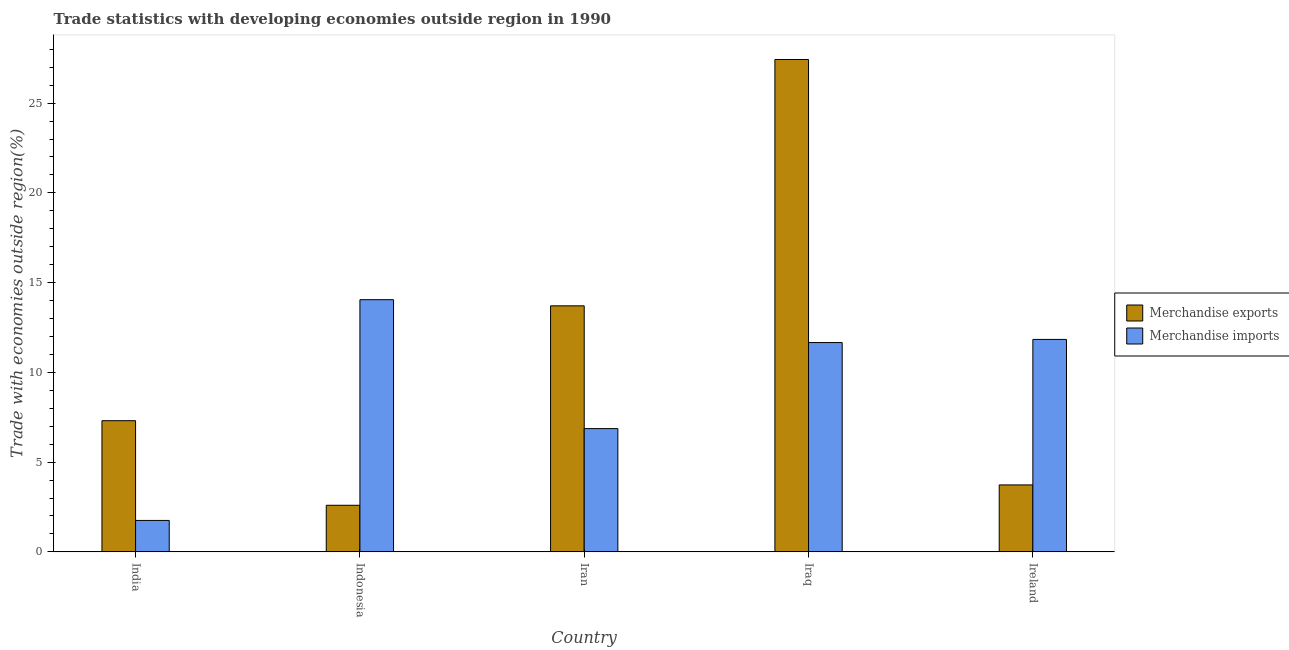How many groups of bars are there?
Offer a very short reply. 5. Are the number of bars on each tick of the X-axis equal?
Give a very brief answer. Yes. What is the label of the 4th group of bars from the left?
Your answer should be compact. Iraq. What is the merchandise imports in Iran?
Provide a short and direct response. 6.87. Across all countries, what is the maximum merchandise imports?
Keep it short and to the point. 14.05. Across all countries, what is the minimum merchandise exports?
Give a very brief answer. 2.6. In which country was the merchandise imports maximum?
Your answer should be compact. Indonesia. What is the total merchandise exports in the graph?
Your answer should be very brief. 54.77. What is the difference between the merchandise imports in Iran and that in Ireland?
Provide a succinct answer. -4.97. What is the difference between the merchandise imports in Indonesia and the merchandise exports in India?
Provide a short and direct response. 6.74. What is the average merchandise imports per country?
Provide a short and direct response. 9.23. What is the difference between the merchandise exports and merchandise imports in Indonesia?
Give a very brief answer. -11.45. What is the ratio of the merchandise exports in Indonesia to that in Iran?
Provide a succinct answer. 0.19. Is the difference between the merchandise exports in Indonesia and Iran greater than the difference between the merchandise imports in Indonesia and Iran?
Your answer should be compact. No. What is the difference between the highest and the second highest merchandise imports?
Make the answer very short. 2.21. What is the difference between the highest and the lowest merchandise exports?
Make the answer very short. 24.83. What does the 2nd bar from the right in Ireland represents?
Your answer should be compact. Merchandise exports. Are all the bars in the graph horizontal?
Provide a succinct answer. No. How many countries are there in the graph?
Offer a terse response. 5. Does the graph contain grids?
Your response must be concise. No. What is the title of the graph?
Make the answer very short. Trade statistics with developing economies outside region in 1990. Does "Forest land" appear as one of the legend labels in the graph?
Offer a terse response. No. What is the label or title of the X-axis?
Provide a succinct answer. Country. What is the label or title of the Y-axis?
Provide a short and direct response. Trade with economies outside region(%). What is the Trade with economies outside region(%) in Merchandise exports in India?
Keep it short and to the point. 7.31. What is the Trade with economies outside region(%) in Merchandise imports in India?
Your response must be concise. 1.75. What is the Trade with economies outside region(%) of Merchandise exports in Indonesia?
Your answer should be very brief. 2.6. What is the Trade with economies outside region(%) in Merchandise imports in Indonesia?
Keep it short and to the point. 14.05. What is the Trade with economies outside region(%) in Merchandise exports in Iran?
Offer a very short reply. 13.71. What is the Trade with economies outside region(%) of Merchandise imports in Iran?
Your answer should be very brief. 6.87. What is the Trade with economies outside region(%) of Merchandise exports in Iraq?
Make the answer very short. 27.43. What is the Trade with economies outside region(%) of Merchandise imports in Iraq?
Your answer should be compact. 11.66. What is the Trade with economies outside region(%) in Merchandise exports in Ireland?
Your answer should be very brief. 3.73. What is the Trade with economies outside region(%) in Merchandise imports in Ireland?
Your response must be concise. 11.84. Across all countries, what is the maximum Trade with economies outside region(%) of Merchandise exports?
Provide a succinct answer. 27.43. Across all countries, what is the maximum Trade with economies outside region(%) of Merchandise imports?
Keep it short and to the point. 14.05. Across all countries, what is the minimum Trade with economies outside region(%) in Merchandise exports?
Offer a very short reply. 2.6. Across all countries, what is the minimum Trade with economies outside region(%) in Merchandise imports?
Keep it short and to the point. 1.75. What is the total Trade with economies outside region(%) in Merchandise exports in the graph?
Your response must be concise. 54.77. What is the total Trade with economies outside region(%) of Merchandise imports in the graph?
Your answer should be compact. 46.17. What is the difference between the Trade with economies outside region(%) of Merchandise exports in India and that in Indonesia?
Offer a terse response. 4.71. What is the difference between the Trade with economies outside region(%) of Merchandise imports in India and that in Indonesia?
Keep it short and to the point. -12.3. What is the difference between the Trade with economies outside region(%) in Merchandise exports in India and that in Iran?
Offer a terse response. -6.4. What is the difference between the Trade with economies outside region(%) of Merchandise imports in India and that in Iran?
Ensure brevity in your answer.  -5.12. What is the difference between the Trade with economies outside region(%) in Merchandise exports in India and that in Iraq?
Provide a short and direct response. -20.12. What is the difference between the Trade with economies outside region(%) in Merchandise imports in India and that in Iraq?
Provide a succinct answer. -9.91. What is the difference between the Trade with economies outside region(%) of Merchandise exports in India and that in Ireland?
Provide a succinct answer. 3.58. What is the difference between the Trade with economies outside region(%) in Merchandise imports in India and that in Ireland?
Give a very brief answer. -10.08. What is the difference between the Trade with economies outside region(%) in Merchandise exports in Indonesia and that in Iran?
Offer a very short reply. -11.11. What is the difference between the Trade with economies outside region(%) of Merchandise imports in Indonesia and that in Iran?
Your answer should be very brief. 7.18. What is the difference between the Trade with economies outside region(%) in Merchandise exports in Indonesia and that in Iraq?
Give a very brief answer. -24.83. What is the difference between the Trade with economies outside region(%) in Merchandise imports in Indonesia and that in Iraq?
Keep it short and to the point. 2.39. What is the difference between the Trade with economies outside region(%) in Merchandise exports in Indonesia and that in Ireland?
Offer a very short reply. -1.13. What is the difference between the Trade with economies outside region(%) of Merchandise imports in Indonesia and that in Ireland?
Provide a succinct answer. 2.21. What is the difference between the Trade with economies outside region(%) in Merchandise exports in Iran and that in Iraq?
Provide a short and direct response. -13.72. What is the difference between the Trade with economies outside region(%) in Merchandise imports in Iran and that in Iraq?
Your response must be concise. -4.79. What is the difference between the Trade with economies outside region(%) in Merchandise exports in Iran and that in Ireland?
Provide a succinct answer. 9.98. What is the difference between the Trade with economies outside region(%) of Merchandise imports in Iran and that in Ireland?
Give a very brief answer. -4.97. What is the difference between the Trade with economies outside region(%) in Merchandise exports in Iraq and that in Ireland?
Your answer should be compact. 23.7. What is the difference between the Trade with economies outside region(%) of Merchandise imports in Iraq and that in Ireland?
Provide a succinct answer. -0.17. What is the difference between the Trade with economies outside region(%) in Merchandise exports in India and the Trade with economies outside region(%) in Merchandise imports in Indonesia?
Keep it short and to the point. -6.74. What is the difference between the Trade with economies outside region(%) of Merchandise exports in India and the Trade with economies outside region(%) of Merchandise imports in Iran?
Ensure brevity in your answer.  0.44. What is the difference between the Trade with economies outside region(%) in Merchandise exports in India and the Trade with economies outside region(%) in Merchandise imports in Iraq?
Provide a short and direct response. -4.35. What is the difference between the Trade with economies outside region(%) in Merchandise exports in India and the Trade with economies outside region(%) in Merchandise imports in Ireland?
Provide a succinct answer. -4.53. What is the difference between the Trade with economies outside region(%) in Merchandise exports in Indonesia and the Trade with economies outside region(%) in Merchandise imports in Iran?
Your response must be concise. -4.27. What is the difference between the Trade with economies outside region(%) in Merchandise exports in Indonesia and the Trade with economies outside region(%) in Merchandise imports in Iraq?
Provide a succinct answer. -9.07. What is the difference between the Trade with economies outside region(%) of Merchandise exports in Indonesia and the Trade with economies outside region(%) of Merchandise imports in Ireland?
Your answer should be very brief. -9.24. What is the difference between the Trade with economies outside region(%) of Merchandise exports in Iran and the Trade with economies outside region(%) of Merchandise imports in Iraq?
Your answer should be very brief. 2.05. What is the difference between the Trade with economies outside region(%) in Merchandise exports in Iran and the Trade with economies outside region(%) in Merchandise imports in Ireland?
Ensure brevity in your answer.  1.87. What is the difference between the Trade with economies outside region(%) of Merchandise exports in Iraq and the Trade with economies outside region(%) of Merchandise imports in Ireland?
Offer a very short reply. 15.59. What is the average Trade with economies outside region(%) of Merchandise exports per country?
Ensure brevity in your answer.  10.95. What is the average Trade with economies outside region(%) of Merchandise imports per country?
Ensure brevity in your answer.  9.23. What is the difference between the Trade with economies outside region(%) of Merchandise exports and Trade with economies outside region(%) of Merchandise imports in India?
Provide a succinct answer. 5.56. What is the difference between the Trade with economies outside region(%) of Merchandise exports and Trade with economies outside region(%) of Merchandise imports in Indonesia?
Your answer should be compact. -11.45. What is the difference between the Trade with economies outside region(%) in Merchandise exports and Trade with economies outside region(%) in Merchandise imports in Iran?
Provide a short and direct response. 6.84. What is the difference between the Trade with economies outside region(%) of Merchandise exports and Trade with economies outside region(%) of Merchandise imports in Iraq?
Provide a succinct answer. 15.77. What is the difference between the Trade with economies outside region(%) of Merchandise exports and Trade with economies outside region(%) of Merchandise imports in Ireland?
Your response must be concise. -8.11. What is the ratio of the Trade with economies outside region(%) of Merchandise exports in India to that in Indonesia?
Offer a terse response. 2.81. What is the ratio of the Trade with economies outside region(%) in Merchandise imports in India to that in Indonesia?
Your answer should be compact. 0.12. What is the ratio of the Trade with economies outside region(%) in Merchandise exports in India to that in Iran?
Offer a very short reply. 0.53. What is the ratio of the Trade with economies outside region(%) in Merchandise imports in India to that in Iran?
Your response must be concise. 0.26. What is the ratio of the Trade with economies outside region(%) in Merchandise exports in India to that in Iraq?
Ensure brevity in your answer.  0.27. What is the ratio of the Trade with economies outside region(%) in Merchandise imports in India to that in Iraq?
Give a very brief answer. 0.15. What is the ratio of the Trade with economies outside region(%) in Merchandise exports in India to that in Ireland?
Give a very brief answer. 1.96. What is the ratio of the Trade with economies outside region(%) in Merchandise imports in India to that in Ireland?
Offer a terse response. 0.15. What is the ratio of the Trade with economies outside region(%) in Merchandise exports in Indonesia to that in Iran?
Offer a very short reply. 0.19. What is the ratio of the Trade with economies outside region(%) in Merchandise imports in Indonesia to that in Iran?
Provide a short and direct response. 2.05. What is the ratio of the Trade with economies outside region(%) of Merchandise exports in Indonesia to that in Iraq?
Make the answer very short. 0.09. What is the ratio of the Trade with economies outside region(%) of Merchandise imports in Indonesia to that in Iraq?
Ensure brevity in your answer.  1.2. What is the ratio of the Trade with economies outside region(%) in Merchandise exports in Indonesia to that in Ireland?
Your answer should be very brief. 0.7. What is the ratio of the Trade with economies outside region(%) in Merchandise imports in Indonesia to that in Ireland?
Give a very brief answer. 1.19. What is the ratio of the Trade with economies outside region(%) of Merchandise exports in Iran to that in Iraq?
Ensure brevity in your answer.  0.5. What is the ratio of the Trade with economies outside region(%) of Merchandise imports in Iran to that in Iraq?
Provide a succinct answer. 0.59. What is the ratio of the Trade with economies outside region(%) of Merchandise exports in Iran to that in Ireland?
Ensure brevity in your answer.  3.67. What is the ratio of the Trade with economies outside region(%) of Merchandise imports in Iran to that in Ireland?
Offer a very short reply. 0.58. What is the ratio of the Trade with economies outside region(%) in Merchandise exports in Iraq to that in Ireland?
Keep it short and to the point. 7.35. What is the difference between the highest and the second highest Trade with economies outside region(%) in Merchandise exports?
Your answer should be very brief. 13.72. What is the difference between the highest and the second highest Trade with economies outside region(%) in Merchandise imports?
Ensure brevity in your answer.  2.21. What is the difference between the highest and the lowest Trade with economies outside region(%) of Merchandise exports?
Make the answer very short. 24.83. What is the difference between the highest and the lowest Trade with economies outside region(%) in Merchandise imports?
Offer a very short reply. 12.3. 